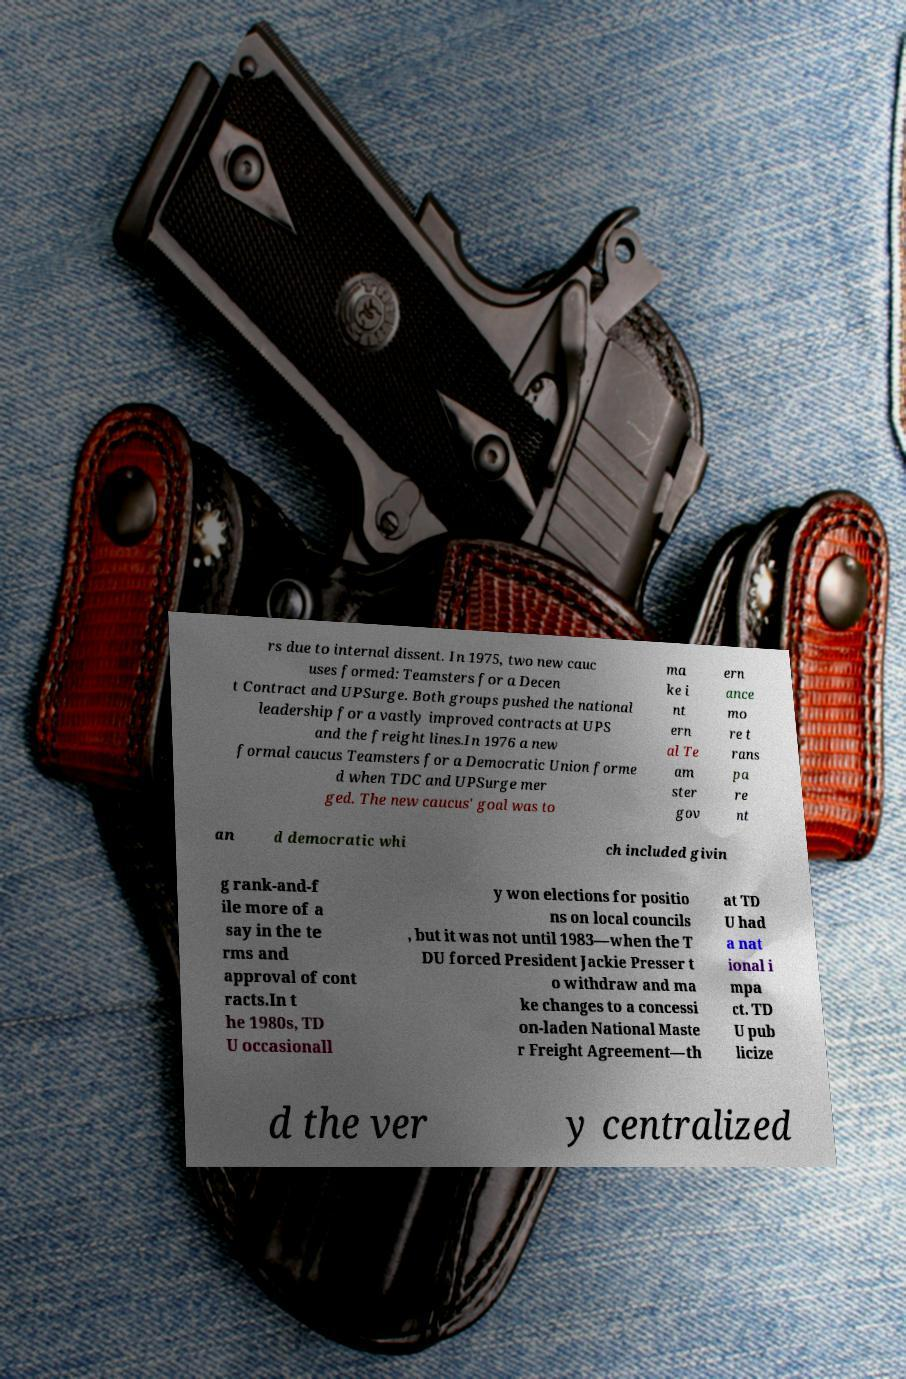Could you extract and type out the text from this image? rs due to internal dissent. In 1975, two new cauc uses formed: Teamsters for a Decen t Contract and UPSurge. Both groups pushed the national leadership for a vastly improved contracts at UPS and the freight lines.In 1976 a new formal caucus Teamsters for a Democratic Union forme d when TDC and UPSurge mer ged. The new caucus' goal was to ma ke i nt ern al Te am ster gov ern ance mo re t rans pa re nt an d democratic whi ch included givin g rank-and-f ile more of a say in the te rms and approval of cont racts.In t he 1980s, TD U occasionall y won elections for positio ns on local councils , but it was not until 1983—when the T DU forced President Jackie Presser t o withdraw and ma ke changes to a concessi on-laden National Maste r Freight Agreement—th at TD U had a nat ional i mpa ct. TD U pub licize d the ver y centralized 